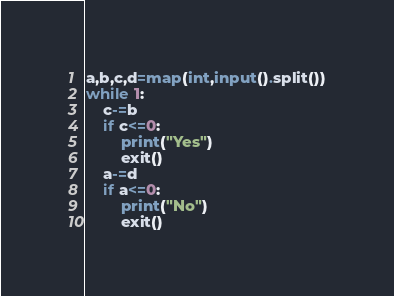<code> <loc_0><loc_0><loc_500><loc_500><_Python_>a,b,c,d=map(int,input().split())
while 1:
    c-=b
    if c<=0:
        print("Yes")
        exit()
    a-=d
    if a<=0:
        print("No")
        exit()
</code> 